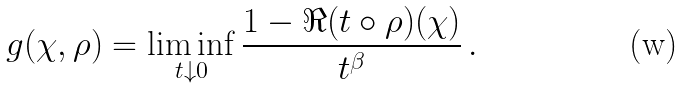Convert formula to latex. <formula><loc_0><loc_0><loc_500><loc_500>g ( \chi , \rho ) = \liminf _ { t \downarrow 0 } \frac { 1 - \Re ( t \circ \rho ) ( \chi ) } { t ^ { \beta } } \, .</formula> 